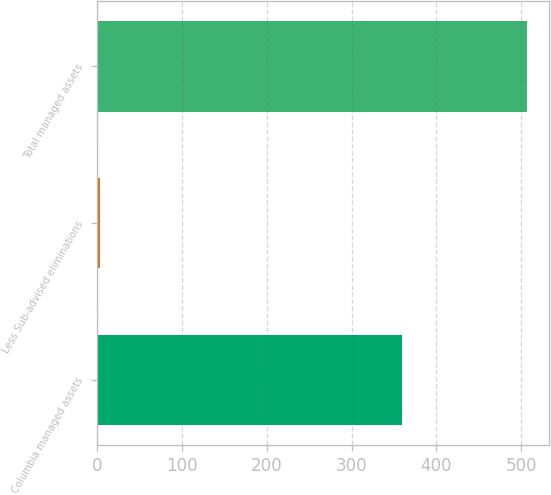Convert chart. <chart><loc_0><loc_0><loc_500><loc_500><bar_chart><fcel>Columbia managed assets<fcel>Less Sub-advised eliminations<fcel>Total managed assets<nl><fcel>359.7<fcel>3.3<fcel>507.3<nl></chart> 